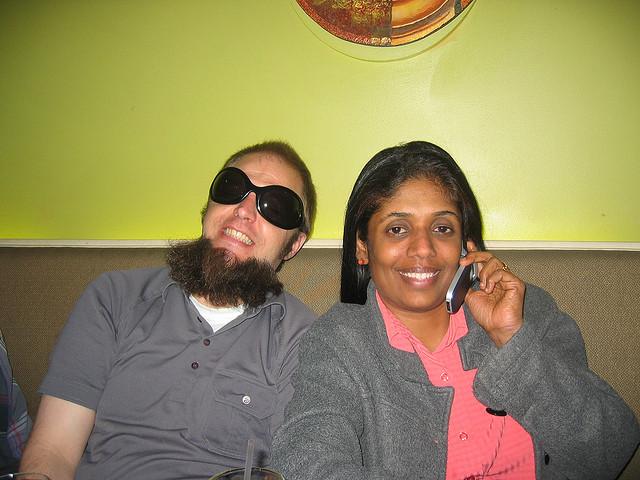What color is this girl's shirt?
Answer briefly. Pink. Is the woman wearing glasses?
Concise answer only. No. What is the women doing?
Answer briefly. Talking. What is the man doing?
Write a very short answer. Smiling. What color is the wall?
Quick response, please. Green. What color are her eyes?
Quick response, please. Brown. Do you think these two people are married?
Keep it brief. No. What color is the woman's jacket?
Be succinct. Gray. What color is the lady's jacket?
Answer briefly. Gray. Is the woman using a flip phone?
Answer briefly. Yes. Are those girls sunglasses?
Give a very brief answer. Yes. Is the person on the left wearing a wig?
Quick response, please. No. What color are the girl's lips?
Write a very short answer. Brown. 